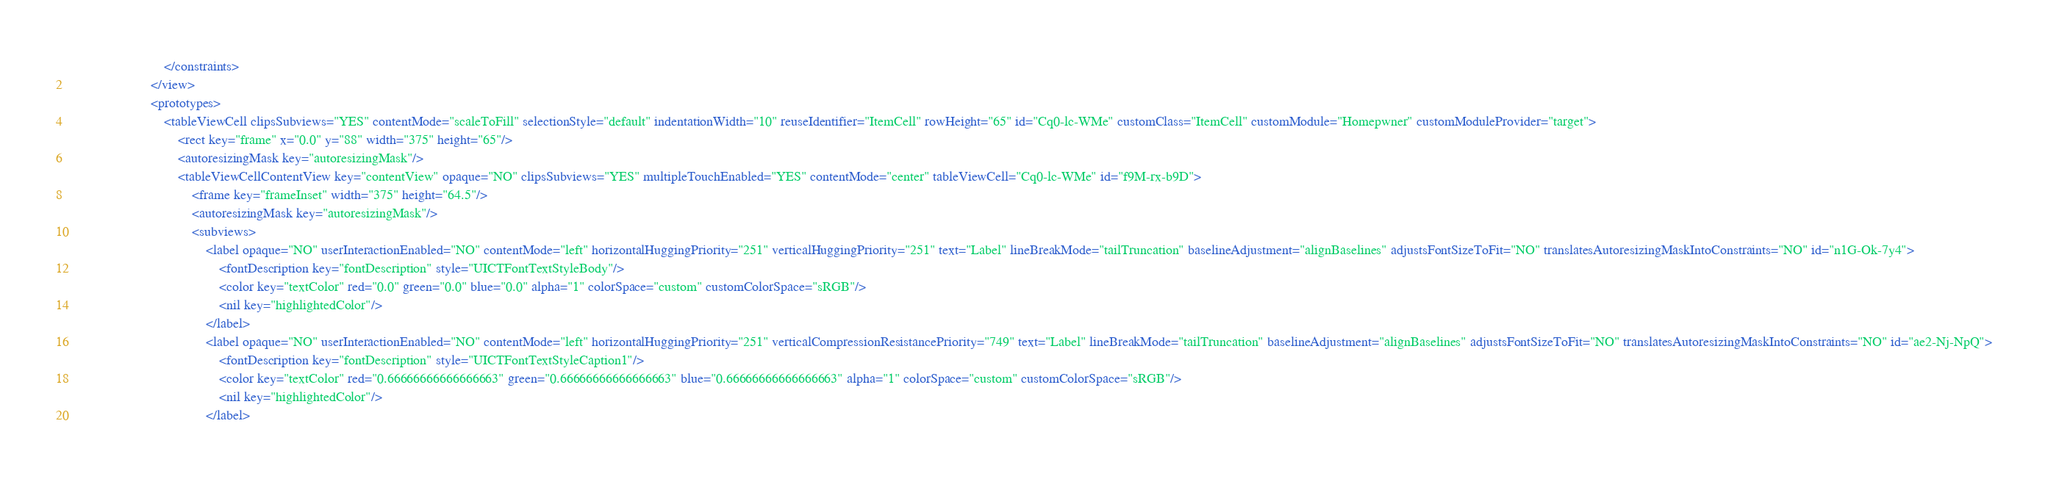Convert code to text. <code><loc_0><loc_0><loc_500><loc_500><_XML_>                            </constraints>
                        </view>
                        <prototypes>
                            <tableViewCell clipsSubviews="YES" contentMode="scaleToFill" selectionStyle="default" indentationWidth="10" reuseIdentifier="ItemCell" rowHeight="65" id="Cq0-lc-WMe" customClass="ItemCell" customModule="Homepwner" customModuleProvider="target">
                                <rect key="frame" x="0.0" y="88" width="375" height="65"/>
                                <autoresizingMask key="autoresizingMask"/>
                                <tableViewCellContentView key="contentView" opaque="NO" clipsSubviews="YES" multipleTouchEnabled="YES" contentMode="center" tableViewCell="Cq0-lc-WMe" id="f9M-rx-b9D">
                                    <frame key="frameInset" width="375" height="64.5"/>
                                    <autoresizingMask key="autoresizingMask"/>
                                    <subviews>
                                        <label opaque="NO" userInteractionEnabled="NO" contentMode="left" horizontalHuggingPriority="251" verticalHuggingPriority="251" text="Label" lineBreakMode="tailTruncation" baselineAdjustment="alignBaselines" adjustsFontSizeToFit="NO" translatesAutoresizingMaskIntoConstraints="NO" id="n1G-Ok-7y4">
                                            <fontDescription key="fontDescription" style="UICTFontTextStyleBody"/>
                                            <color key="textColor" red="0.0" green="0.0" blue="0.0" alpha="1" colorSpace="custom" customColorSpace="sRGB"/>
                                            <nil key="highlightedColor"/>
                                        </label>
                                        <label opaque="NO" userInteractionEnabled="NO" contentMode="left" horizontalHuggingPriority="251" verticalCompressionResistancePriority="749" text="Label" lineBreakMode="tailTruncation" baselineAdjustment="alignBaselines" adjustsFontSizeToFit="NO" translatesAutoresizingMaskIntoConstraints="NO" id="ae2-Nj-NpQ">
                                            <fontDescription key="fontDescription" style="UICTFontTextStyleCaption1"/>
                                            <color key="textColor" red="0.66666666666666663" green="0.66666666666666663" blue="0.66666666666666663" alpha="1" colorSpace="custom" customColorSpace="sRGB"/>
                                            <nil key="highlightedColor"/>
                                        </label></code> 